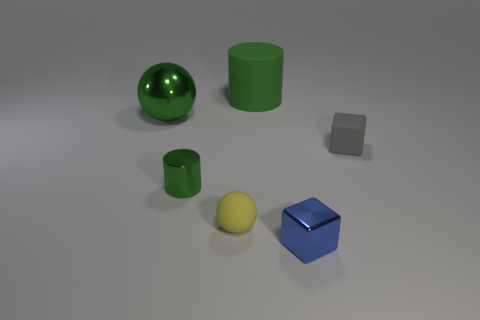Add 1 small blue metal things. How many objects exist? 7 Subtract all cylinders. How many objects are left? 4 Add 4 metal cylinders. How many metal cylinders are left? 5 Add 4 large things. How many large things exist? 6 Subtract 0 yellow cubes. How many objects are left? 6 Subtract all large yellow metallic cylinders. Subtract all yellow matte balls. How many objects are left? 5 